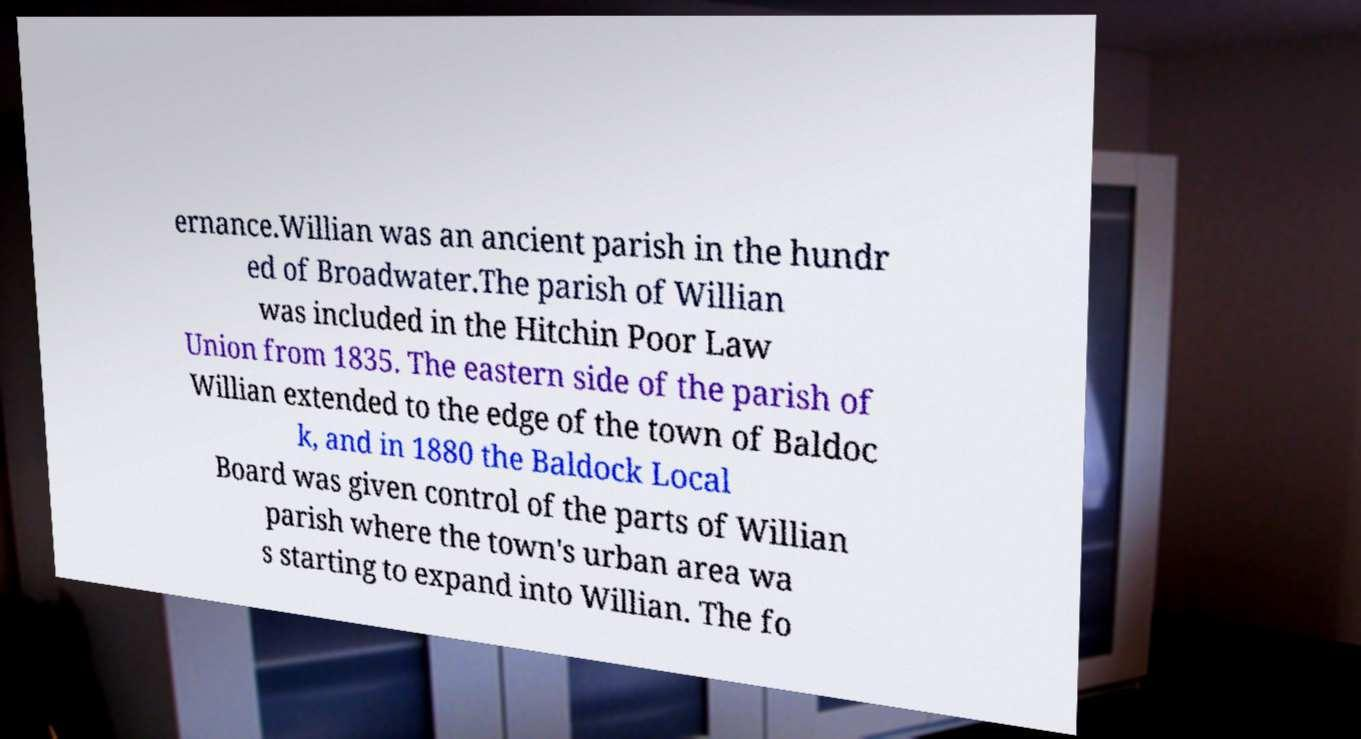Please read and relay the text visible in this image. What does it say? ernance.Willian was an ancient parish in the hundr ed of Broadwater.The parish of Willian was included in the Hitchin Poor Law Union from 1835. The eastern side of the parish of Willian extended to the edge of the town of Baldoc k, and in 1880 the Baldock Local Board was given control of the parts of Willian parish where the town's urban area wa s starting to expand into Willian. The fo 